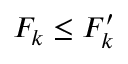<formula> <loc_0><loc_0><loc_500><loc_500>F _ { k } \leq F _ { k } ^ { \prime }</formula> 